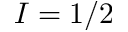<formula> <loc_0><loc_0><loc_500><loc_500>I = 1 / 2</formula> 